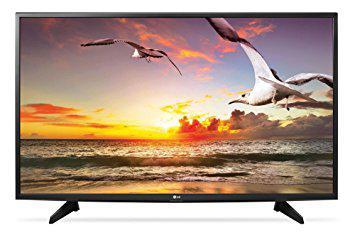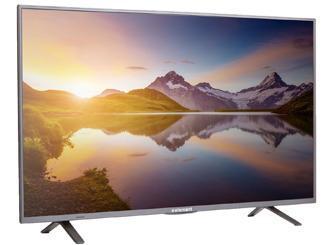The first image is the image on the left, the second image is the image on the right. Examine the images to the left and right. Is the description "Exactly one television has end stands." accurate? Answer yes or no. No. The first image is the image on the left, the second image is the image on the right. Considering the images on both sides, is "Each television shows a wordless nature scene." valid? Answer yes or no. Yes. 